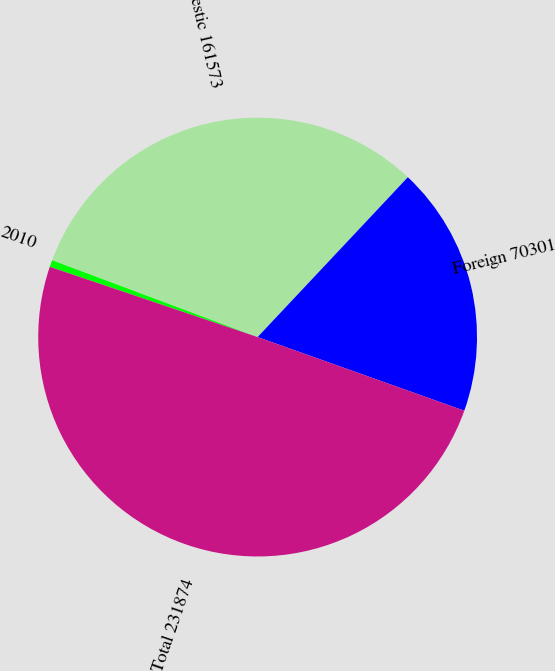Convert chart. <chart><loc_0><loc_0><loc_500><loc_500><pie_chart><fcel>2010<fcel>Domestic 161573<fcel>Foreign 70301<fcel>Total 231874<nl><fcel>0.52%<fcel>31.3%<fcel>18.44%<fcel>49.74%<nl></chart> 